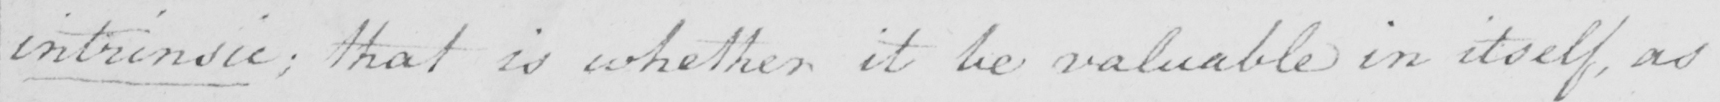Can you read and transcribe this handwriting? intrinsic ; that is whether it be valuable in itself , as 